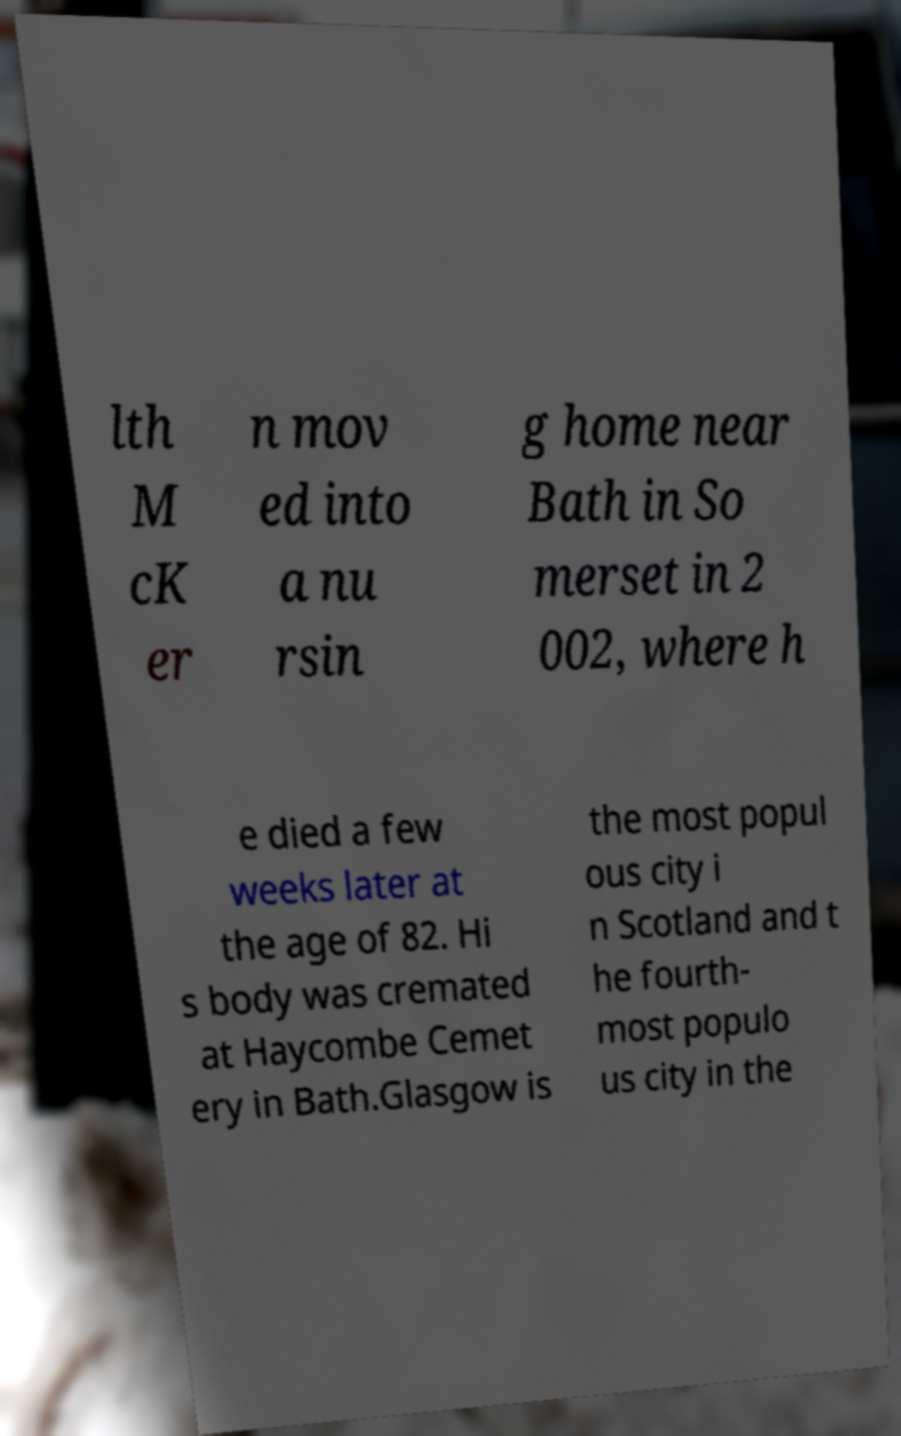Please identify and transcribe the text found in this image. lth M cK er n mov ed into a nu rsin g home near Bath in So merset in 2 002, where h e died a few weeks later at the age of 82. Hi s body was cremated at Haycombe Cemet ery in Bath.Glasgow is the most popul ous city i n Scotland and t he fourth- most populo us city in the 